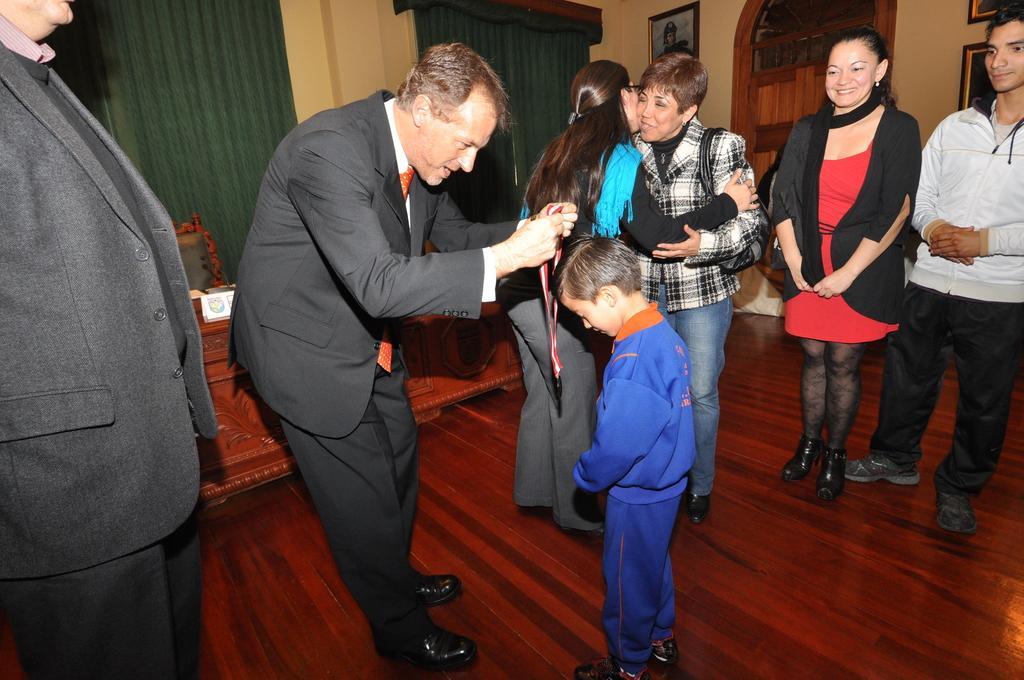Could you give a brief overview of what you see in this image? In this image a boy wearing a blue jacket is standing on the floor. Few persons are standing on the floor. A person wearing suit and tie is holding medal in his hand. Behind him there is a table and a chair. Left side there is a person wearing a suit is standing on the floor. There are few picture frames attached to the wall. There are few windows covered with curtain. 